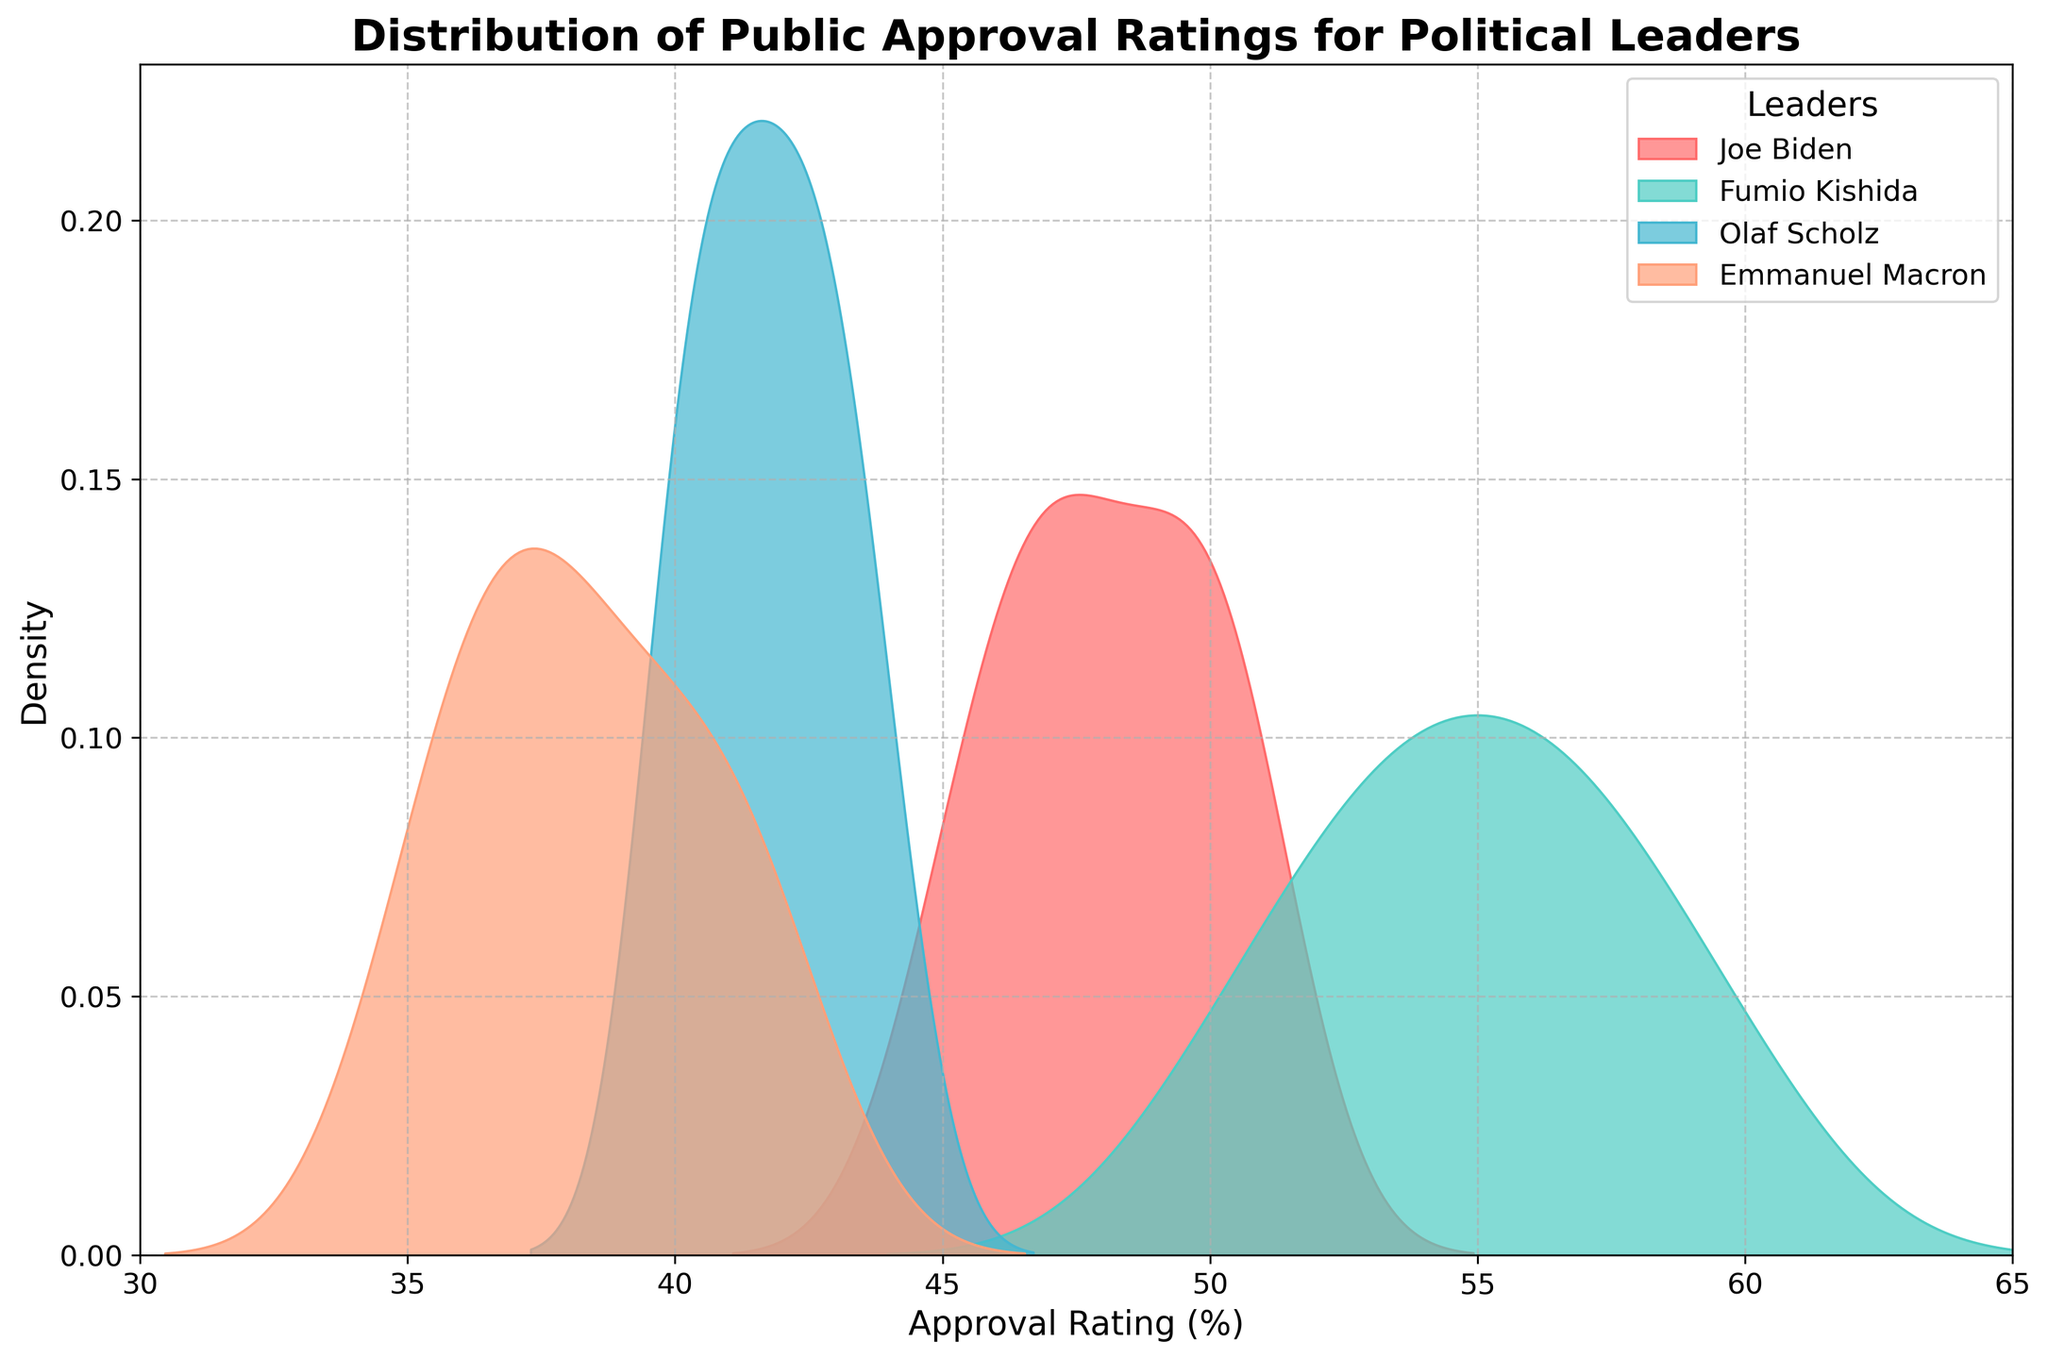How many political leaders are compared in the plot? The title and legend show that there are four leaders being compared in the plot.
Answer: Four What is the peak density value for Joe Biden's approval rating? By examining the plot, we see that the highest density point for Joe Biden is around his most frequent approval rating, which can be identified by the peak of the distribution curve for Joe Biden's color.
Answer: Approximately 50% Which leader has the highest maximum approval rating displayed on the plot? The plot's x-axis ranges from 30% to 65%. The highest maximum approval rating, represented by the curve extending furthest to the right, belongs to Fumio Kishida.
Answer: Fumio Kishida What is the range of approval ratings for Emmanuel Macron displayed on the plot? By looking at the spread of Emmanuel Macron’s distribution, we can see that it spans from approximately 35% to 42%.
Answer: 35% to 42% Compare the central tendencies (means) of Olaf Scholz and Joe Biden's approval ratings. Which one is higher? By comparing the peaks of the density plots for Olaf Scholz and Joe Biden, we can determine that Joe Biden's central tendency (around 50%) is slightly higher than Olaf Scholz's (around 43%).
Answer: Joe Biden Which leader has the most spread-out (least concentrated) distribution of approval ratings? A more spread-out distribution will have a broader base along the x-axis without sharp peaks. Fumio Kishida's distribution appears more spread out, evidenced by a lower peak and a wider range around 55%.
Answer: Fumio Kishida Is there any month where Fumio Kishida's approval rating overlaps with Joe Biden’s in terms of percentage? To find overlaps, we compare the densities where their ratings are close. Both Fumio Kishida and Joe Biden have densities around 50% where their curves overlap.
Answer: Yes, around 50% What is the density value of Emmanuel Macron's approval rating at 40%? By locating 40% on the x-axis and finding Emmanuel Macron’s density curve height at that point, we estimate the density to be around 0.05 (not exact as density plots represent smooth estimations).
Answer: Approximately 0.05 Which two leaders have the closest central tendencies in their approval ratings? By examining the peaks of the curves, Olaf Scholz and Emmanuel Macron have relatively close central tendencies, around 43% and 40% respectively.
Answer: Olaf Scholz and Emmanuel Macron 